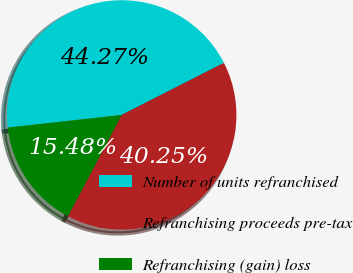Convert chart. <chart><loc_0><loc_0><loc_500><loc_500><pie_chart><fcel>Number of units refranchised<fcel>Refranchising proceeds pre-tax<fcel>Refranchising (gain) loss<nl><fcel>44.27%<fcel>40.25%<fcel>15.48%<nl></chart> 